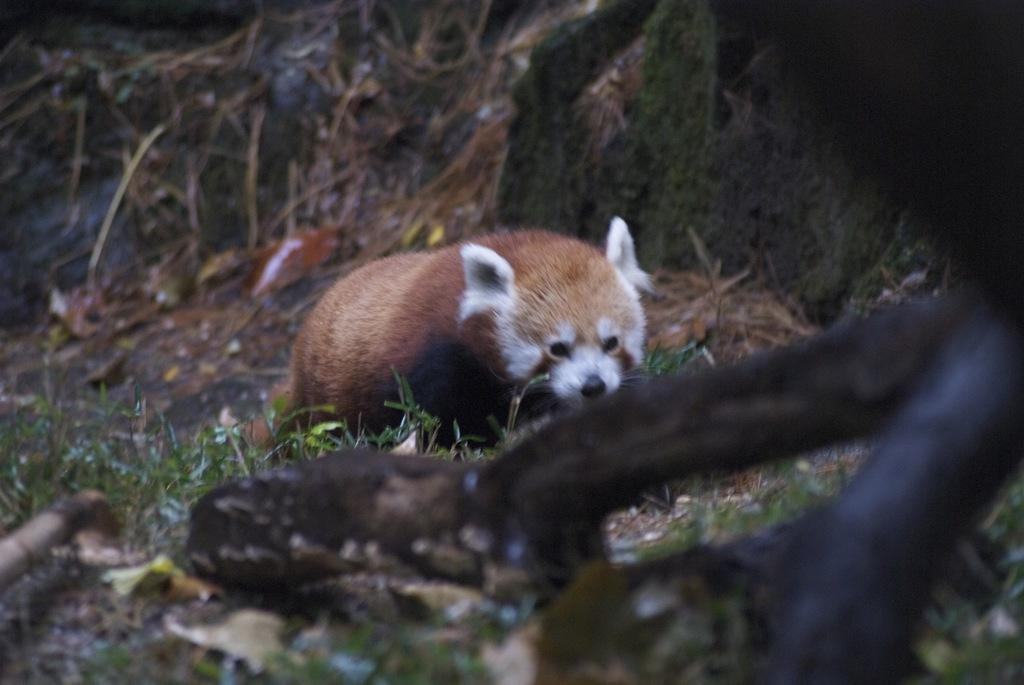What type of animal is in the image? There is an animal in the image, but the specific type cannot be determined from the provided facts. What colors can be seen on the animal? The animal has white and brown colors. What is the natural setting visible in the image? The background of the image includes green grass. What does the boy taste like in the image? There is no boy present in the image, so it is not possible to determine what he might taste like. 